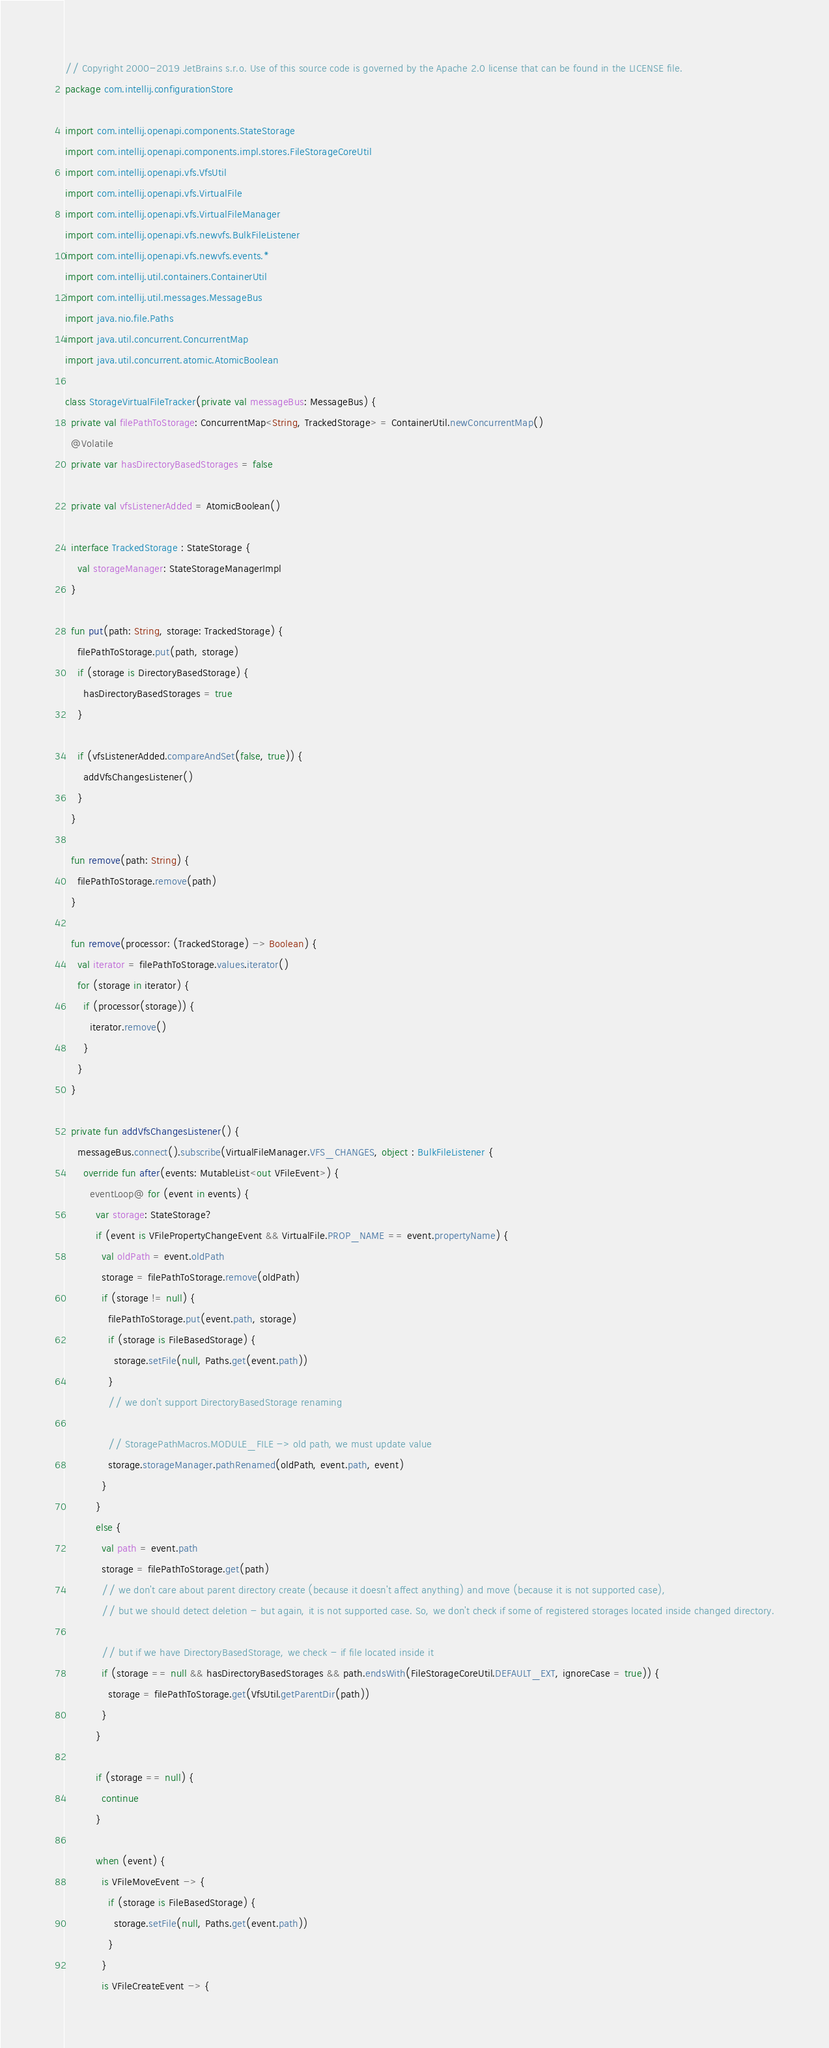Convert code to text. <code><loc_0><loc_0><loc_500><loc_500><_Kotlin_>// Copyright 2000-2019 JetBrains s.r.o. Use of this source code is governed by the Apache 2.0 license that can be found in the LICENSE file.
package com.intellij.configurationStore

import com.intellij.openapi.components.StateStorage
import com.intellij.openapi.components.impl.stores.FileStorageCoreUtil
import com.intellij.openapi.vfs.VfsUtil
import com.intellij.openapi.vfs.VirtualFile
import com.intellij.openapi.vfs.VirtualFileManager
import com.intellij.openapi.vfs.newvfs.BulkFileListener
import com.intellij.openapi.vfs.newvfs.events.*
import com.intellij.util.containers.ContainerUtil
import com.intellij.util.messages.MessageBus
import java.nio.file.Paths
import java.util.concurrent.ConcurrentMap
import java.util.concurrent.atomic.AtomicBoolean

class StorageVirtualFileTracker(private val messageBus: MessageBus) {
  private val filePathToStorage: ConcurrentMap<String, TrackedStorage> = ContainerUtil.newConcurrentMap()
  @Volatile
  private var hasDirectoryBasedStorages = false

  private val vfsListenerAdded = AtomicBoolean()

  interface TrackedStorage : StateStorage {
    val storageManager: StateStorageManagerImpl
  }

  fun put(path: String, storage: TrackedStorage) {
    filePathToStorage.put(path, storage)
    if (storage is DirectoryBasedStorage) {
      hasDirectoryBasedStorages = true
    }

    if (vfsListenerAdded.compareAndSet(false, true)) {
      addVfsChangesListener()
    }
  }

  fun remove(path: String) {
    filePathToStorage.remove(path)
  }

  fun remove(processor: (TrackedStorage) -> Boolean) {
    val iterator = filePathToStorage.values.iterator()
    for (storage in iterator) {
      if (processor(storage)) {
        iterator.remove()
      }
    }
  }

  private fun addVfsChangesListener() {
    messageBus.connect().subscribe(VirtualFileManager.VFS_CHANGES, object : BulkFileListener {
      override fun after(events: MutableList<out VFileEvent>) {
        eventLoop@ for (event in events) {
          var storage: StateStorage?
          if (event is VFilePropertyChangeEvent && VirtualFile.PROP_NAME == event.propertyName) {
            val oldPath = event.oldPath
            storage = filePathToStorage.remove(oldPath)
            if (storage != null) {
              filePathToStorage.put(event.path, storage)
              if (storage is FileBasedStorage) {
                storage.setFile(null, Paths.get(event.path))
              }
              // we don't support DirectoryBasedStorage renaming

              // StoragePathMacros.MODULE_FILE -> old path, we must update value
              storage.storageManager.pathRenamed(oldPath, event.path, event)
            }
          }
          else {
            val path = event.path
            storage = filePathToStorage.get(path)
            // we don't care about parent directory create (because it doesn't affect anything) and move (because it is not supported case),
            // but we should detect deletion - but again, it is not supported case. So, we don't check if some of registered storages located inside changed directory.

            // but if we have DirectoryBasedStorage, we check - if file located inside it
            if (storage == null && hasDirectoryBasedStorages && path.endsWith(FileStorageCoreUtil.DEFAULT_EXT, ignoreCase = true)) {
              storage = filePathToStorage.get(VfsUtil.getParentDir(path))
            }
          }

          if (storage == null) {
            continue
          }

          when (event) {
            is VFileMoveEvent -> {
              if (storage is FileBasedStorage) {
                storage.setFile(null, Paths.get(event.path))
              }
            }
            is VFileCreateEvent -> {</code> 